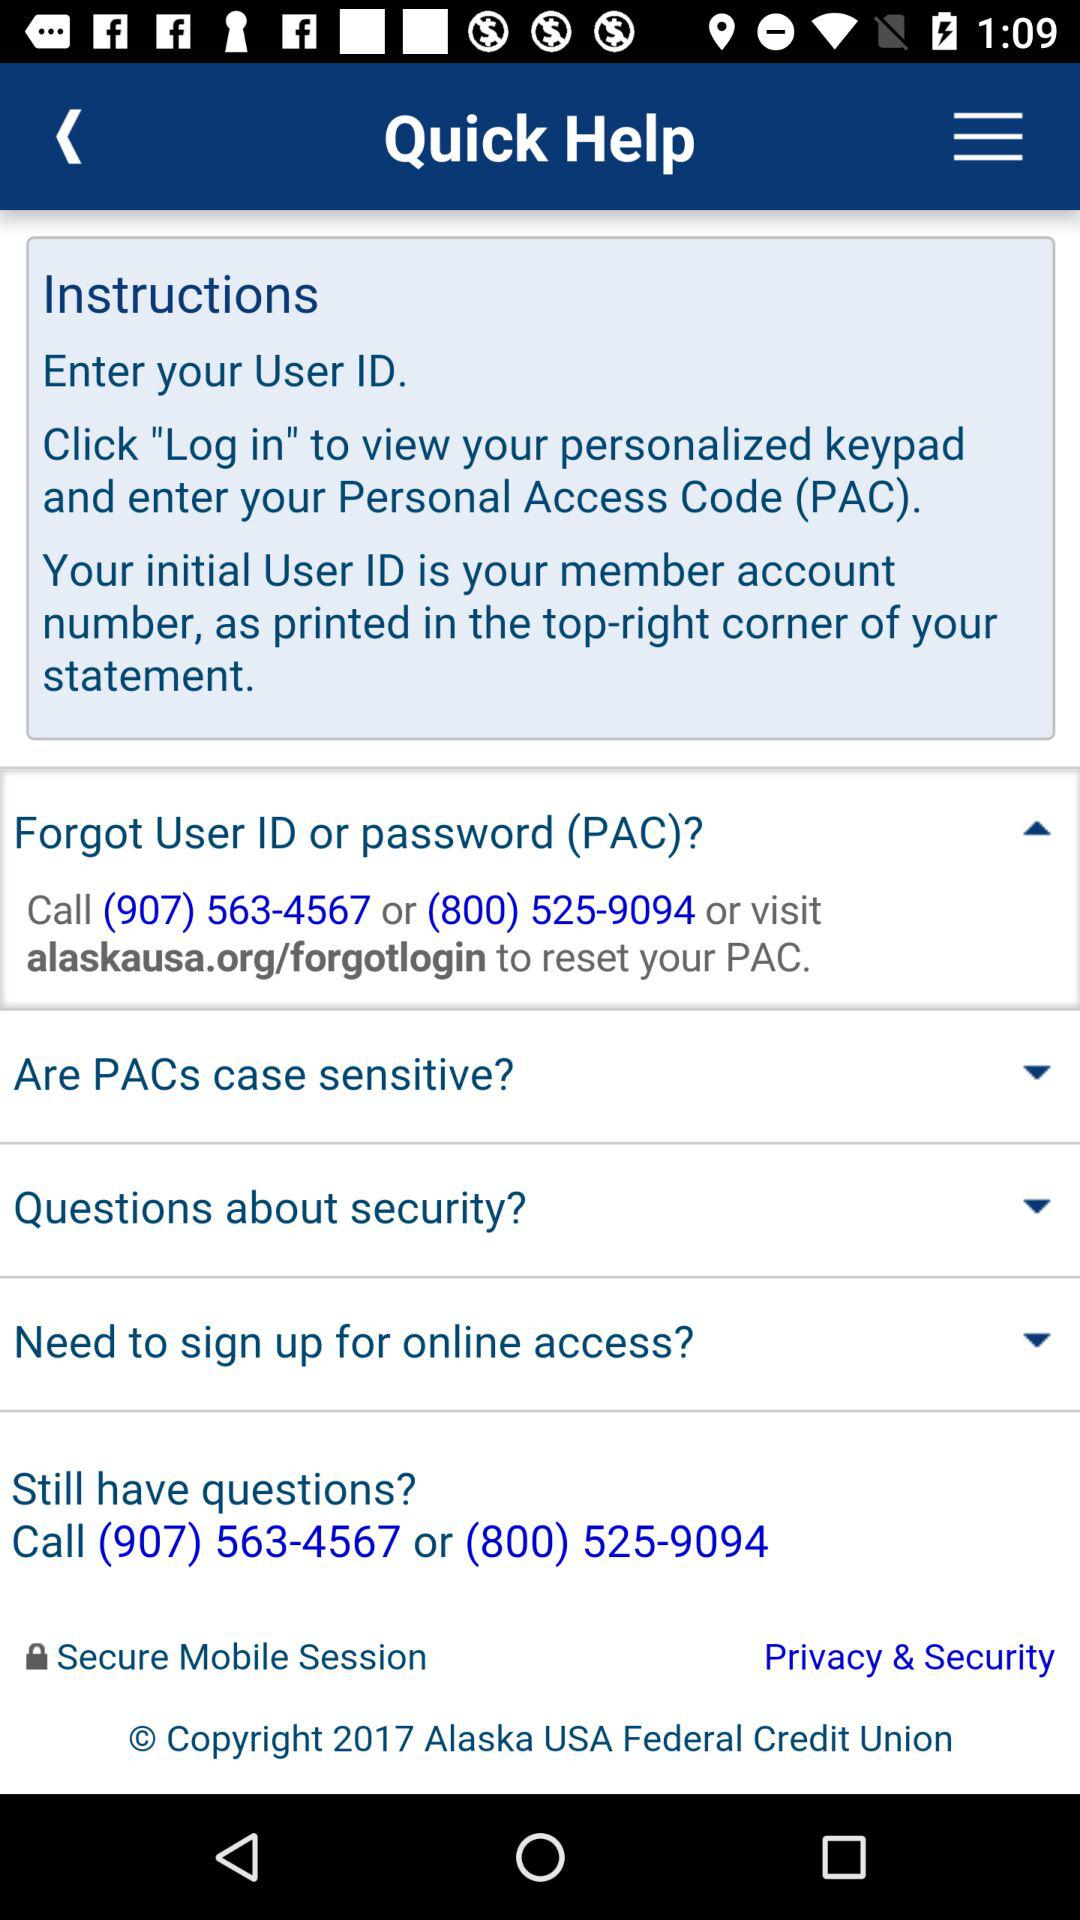What is the name of the user?
When the provided information is insufficient, respond with <no answer>. <no answer> 